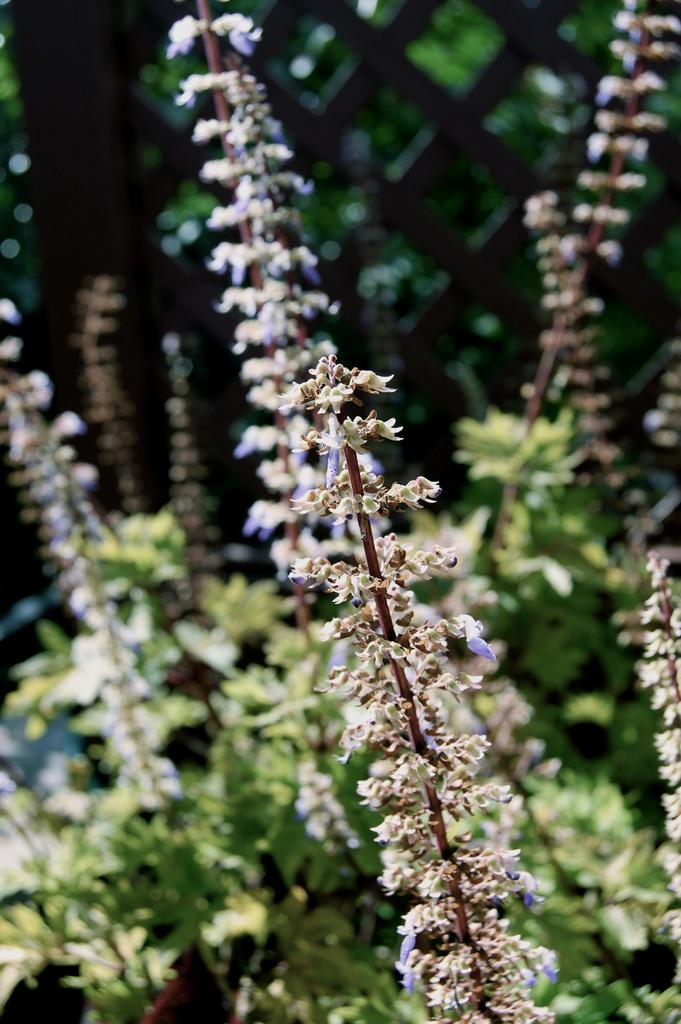What type of plant is present in the image? There is a small flower plant in the image. What color are the leaves on the plant? There are green leaves visible in the image. What other object can be seen in the image? There is a wooden grill in the image. What type of silk material is draped over the plants in the image? There is no silk material present in the image; it only features a small flower plant and green leaves. 